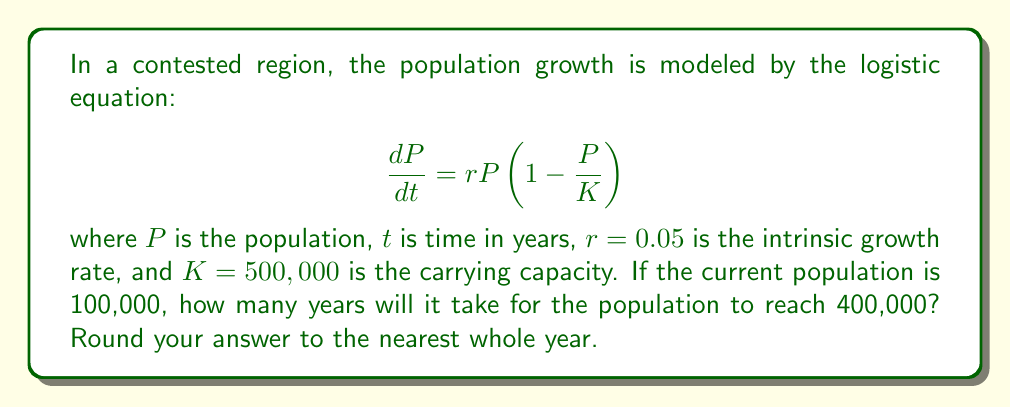Can you answer this question? To solve this problem, we need to use the solution to the logistic equation, which is:

$$P(t) = \frac{K}{1 + (\frac{K}{P_0} - 1)e^{-rt}}$$

Where $P_0$ is the initial population.

Given:
$K = 500,000$
$r = 0.05$
$P_0 = 100,000$
$P(t) = 400,000$ (target population)

Let's solve for $t$:

1) Substitute the values into the equation:

   $$400,000 = \frac{500,000}{1 + (\frac{500,000}{100,000} - 1)e^{-0.05t}}$$

2) Simplify:

   $$400,000 = \frac{500,000}{1 + 4e^{-0.05t}}$$

3) Multiply both sides by $(1 + 4e^{-0.05t})$:

   $$400,000(1 + 4e^{-0.05t}) = 500,000$$

4) Expand:

   $$400,000 + 1,600,000e^{-0.05t} = 500,000$$

5) Subtract 400,000 from both sides:

   $$1,600,000e^{-0.05t} = 100,000$$

6) Divide both sides by 1,600,000:

   $$e^{-0.05t} = \frac{1}{16}$$

7) Take the natural log of both sides:

   $$-0.05t = \ln(\frac{1}{16}) = -\ln(16)$$

8) Divide both sides by -0.05:

   $$t = \frac{\ln(16)}{0.05} \approx 55.45$$

9) Round to the nearest whole year:

   $$t \approx 55 \text{ years}$$
Answer: 55 years 